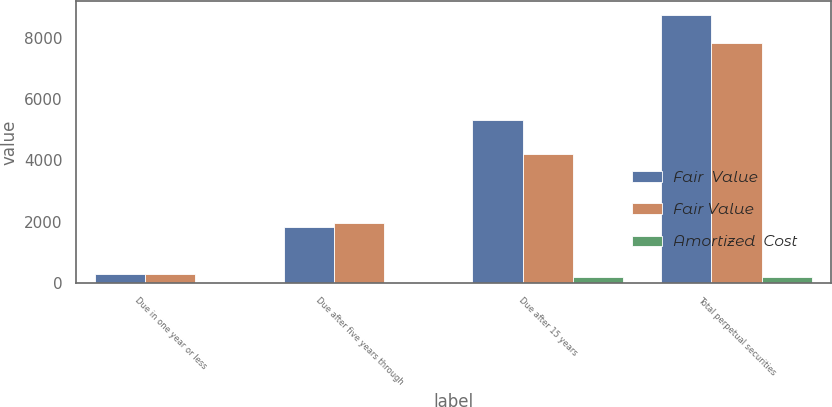<chart> <loc_0><loc_0><loc_500><loc_500><stacked_bar_chart><ecel><fcel>Due in one year or less<fcel>Due after five years through<fcel>Due after 15 years<fcel>Total perpetual securities<nl><fcel>Fair  Value<fcel>290<fcel>1839<fcel>5320<fcel>8760<nl><fcel>Fair Value<fcel>284<fcel>1944<fcel>4213<fcel>7843<nl><fcel>Amortized  Cost<fcel>7<fcel>2<fcel>195<fcel>204<nl></chart> 